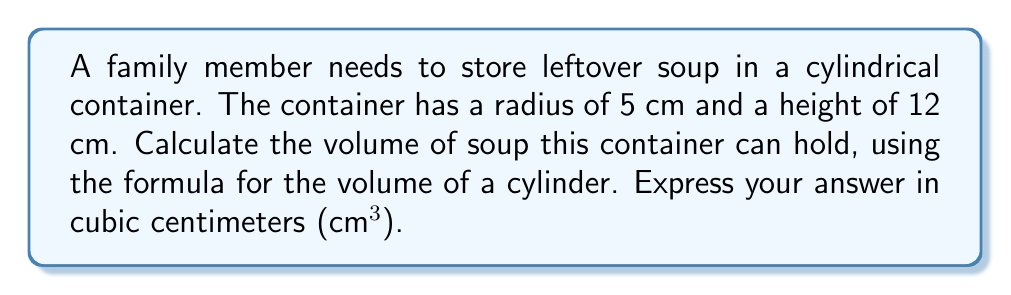Can you answer this question? To solve this problem, we'll use the formula for the volume of a cylinder:

$$V = \pi r^2 h$$

Where:
$V$ = volume
$\pi$ = pi (approximately 3.14159)
$r$ = radius of the base
$h$ = height of the cylinder

Given:
$r = 5$ cm
$h = 12$ cm

Let's substitute these values into the formula:

$$V = \pi (5\text{ cm})^2 (12\text{ cm})$$

Simplify the exponent:
$$V = \pi (25\text{ cm}^2) (12\text{ cm})$$

Multiply the numbers:
$$V = 300\pi\text{ cm}^3$$

Using 3.14159 as an approximation for $\pi$:

$$V \approx 300 \times 3.14159\text{ cm}^3$$
$$V \approx 942.48\text{ cm}^3$$

Rounding to two decimal places:
$$V \approx 942.48\text{ cm}^3$$
Answer: $942.48\text{ cm}^3$ 